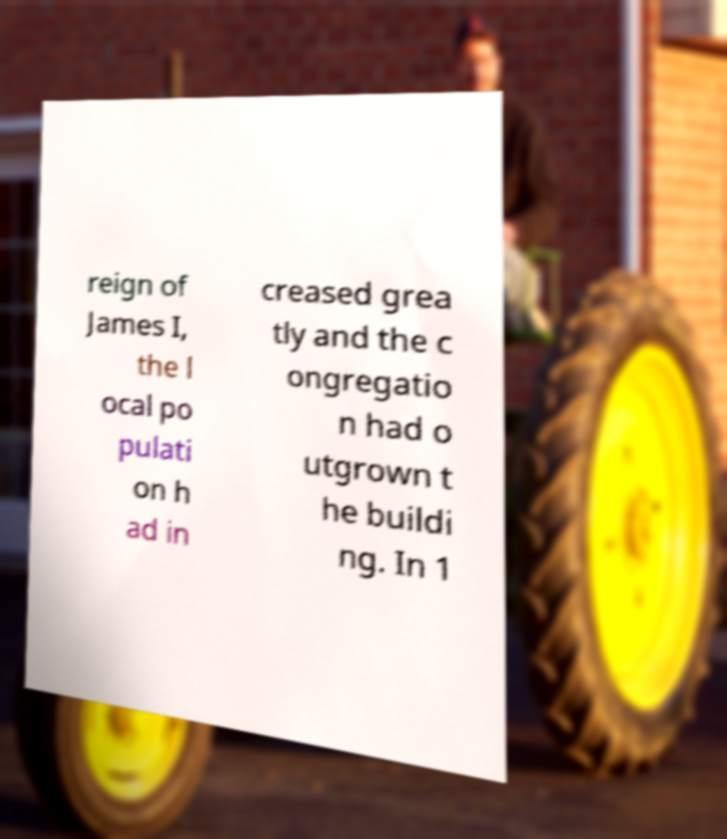I need the written content from this picture converted into text. Can you do that? reign of James I, the l ocal po pulati on h ad in creased grea tly and the c ongregatio n had o utgrown t he buildi ng. In 1 